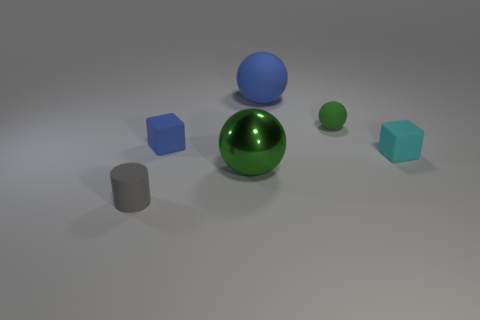Are there any other things that are the same material as the large green thing?
Provide a succinct answer. No. There is a tiny cube that is the same color as the large matte object; what is its material?
Make the answer very short. Rubber. The blue sphere has what size?
Your answer should be very brief. Large. Is the number of large green metallic spheres that are behind the metal sphere greater than the number of blue balls?
Your answer should be compact. No. Are there the same number of small green balls that are in front of the small blue matte cube and big metallic things behind the green matte object?
Make the answer very short. Yes. There is a matte object that is both to the left of the big green metallic sphere and to the right of the gray matte cylinder; what is its color?
Ensure brevity in your answer.  Blue. Are there any other things that have the same size as the blue matte sphere?
Your response must be concise. Yes. Is the number of large matte spheres that are behind the large matte ball greater than the number of cyan blocks that are in front of the tiny green rubber sphere?
Offer a terse response. No. Is the size of the sphere behind the green matte sphere the same as the cyan matte object?
Your answer should be very brief. No. What number of small objects are in front of the green thing that is in front of the rubber block on the left side of the big blue object?
Provide a short and direct response. 1. 